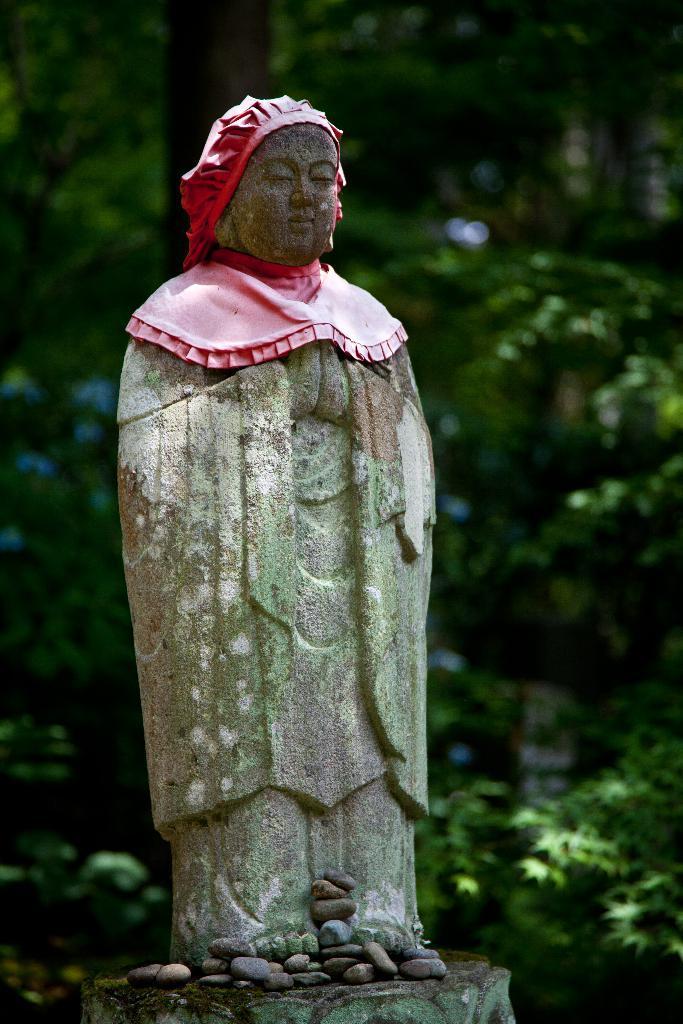How would you summarize this image in a sentence or two? In the center of the image we can see a statue. At the bottom of the image we can see some stones. In the background of the image we can see the trees. 